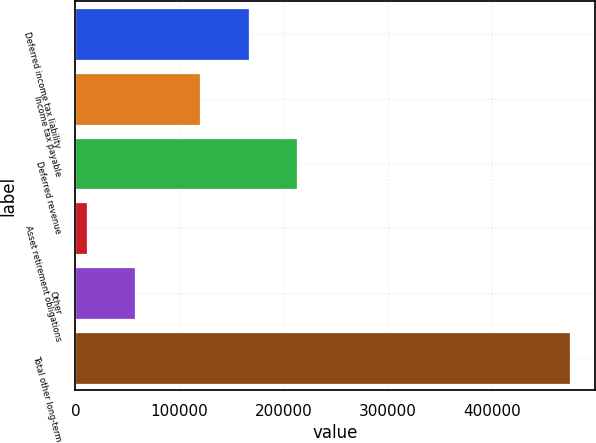Convert chart to OTSL. <chart><loc_0><loc_0><loc_500><loc_500><bar_chart><fcel>Deferred income tax liability<fcel>Income tax payable<fcel>Deferred revenue<fcel>Asset retirement obligations<fcel>Other<fcel>Total other long-term<nl><fcel>166384<fcel>119977<fcel>212791<fcel>11056<fcel>57462.9<fcel>475125<nl></chart> 